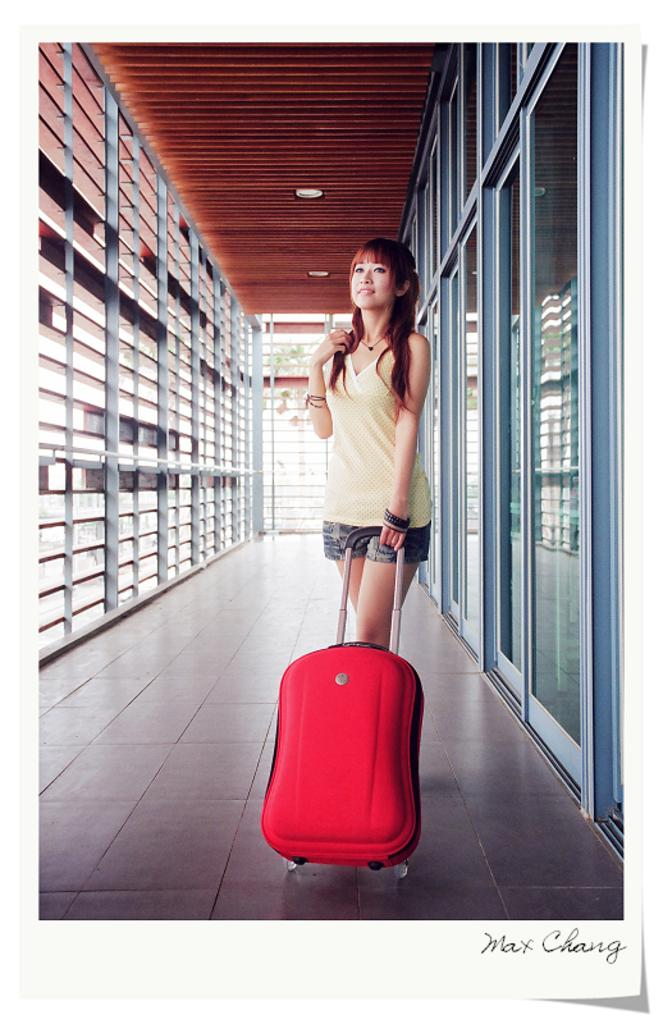Who is present in the image? There is a lady in the image. What is the lady holding in the image? The lady is holding a suitcase. What can be seen in the background of the image? There are windows in the image. What is surrounding the lady in the image? There are grills around the lady. What type of cheese is being served on the grills in the image? There is no cheese or grills being used for cooking in the image; the lady is surrounded by decorative grills. 